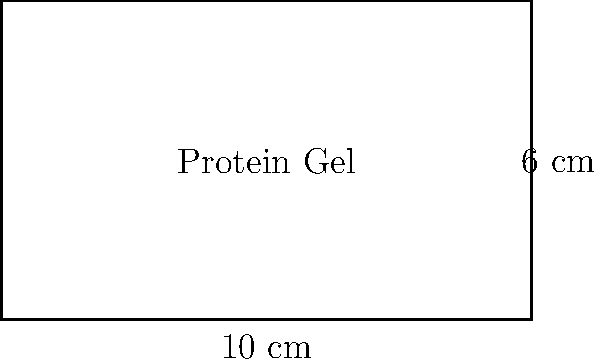A rectangular protein gel electrophoresis apparatus has dimensions of 10 cm by 6 cm. Calculate the area of the gel and the perimeter of the apparatus. How might the size of this gel affect the resolution of protein separation? To solve this problem, we'll calculate the area and perimeter of the rectangular gel apparatus:

1. Area calculation:
   The formula for the area of a rectangle is $A = l \times w$, where $l$ is length and $w$ is width.
   $A = 10 \text{ cm} \times 6 \text{ cm} = 60 \text{ cm}^2$

2. Perimeter calculation:
   The formula for the perimeter of a rectangle is $P = 2l + 2w$
   $P = 2(10 \text{ cm}) + 2(6 \text{ cm}) = 20 \text{ cm} + 12 \text{ cm} = 32 \text{ cm}$

3. Effect on protein separation:
   The size of the gel affects the resolution of protein separation in several ways:
   a) Larger gels allow for better separation of proteins with similar molecular weights.
   b) Increased gel length provides more space for proteins to migrate, improving resolution.
   c) Wider gels can accommodate more samples, allowing for direct comparison of multiple proteins.
   d) However, larger gels require more time and voltage for complete protein migration.

In this case, the 60 cm² gel provides a moderate area for protein separation, suitable for many standard biochemistry experiments. The 32 cm perimeter indicates a compact design, which can be beneficial for efficient heat dissipation during electrophoresis.
Answer: Area: 60 cm², Perimeter: 32 cm. Larger gel size generally improves protein separation resolution but increases run time. 